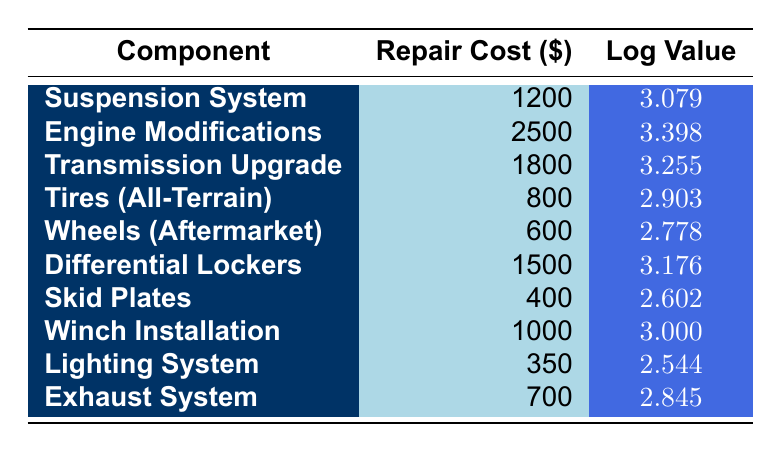What is the repair cost for the Engine Modifications? The repair cost for Engine Modifications is directly stated in the table, which shows a value of 2500.
Answer: 2500 Which component has the highest logarithmic value? The table indicates the logarithmic values, and the Engine Modifications have the highest value at 3.398.
Answer: Engine Modifications What is the sum of the repair costs for the Suspension System and Differential Lockers? The repair cost for the Suspension System is 1200 and for Differential Lockers is 1500. Adding these gives 1200 + 1500 = 2700.
Answer: 2700 Is the repair cost for the Skid Plates less than 500? The repair cost for Skid Plates is stated as 400, which is indeed less than 500.
Answer: Yes What is the average repair cost for all components? To find the average, sum all repair costs: 1200 + 2500 + 1800 + 800 + 600 + 1500 + 400 + 1000 + 350 + 700 = 11500. There are 10 components, so the average is 11500 / 10 = 1150.
Answer: 1150 How does the repair cost of Tires compare to Differential Lockers? The repair cost for Tires (All-Terrain) is 800, while for Differential Lockers it is 1500. Since 800 is less than 1500, Tires are cheaper.
Answer: Tires are cheaper What is the difference in logarithmic values between the Transmission Upgrade and the Exhaust System? The logarithmic value for Transmission Upgrade is 3.255, and for Exhaust System, it is 2.845. The difference is 3.255 - 2.845 = 0.410.
Answer: 0.410 Does the Lighting System have a higher repair cost than the Wheels? The repair cost for Lighting System is 350, while for Wheels (Aftermarket) it is 600. Since 350 is not greater than 600, the statement is false.
Answer: No Which component has a logarithmic value below 3? From the table, the components with logarithmic values below 3 are Tires (All-Terrain) at 2.903, Wheels (Aftermarket) at 2.778, Skid Plates at 2.602, and Lighting System at 2.544.
Answer: Tires, Wheels, Skid Plates, Lighting System 